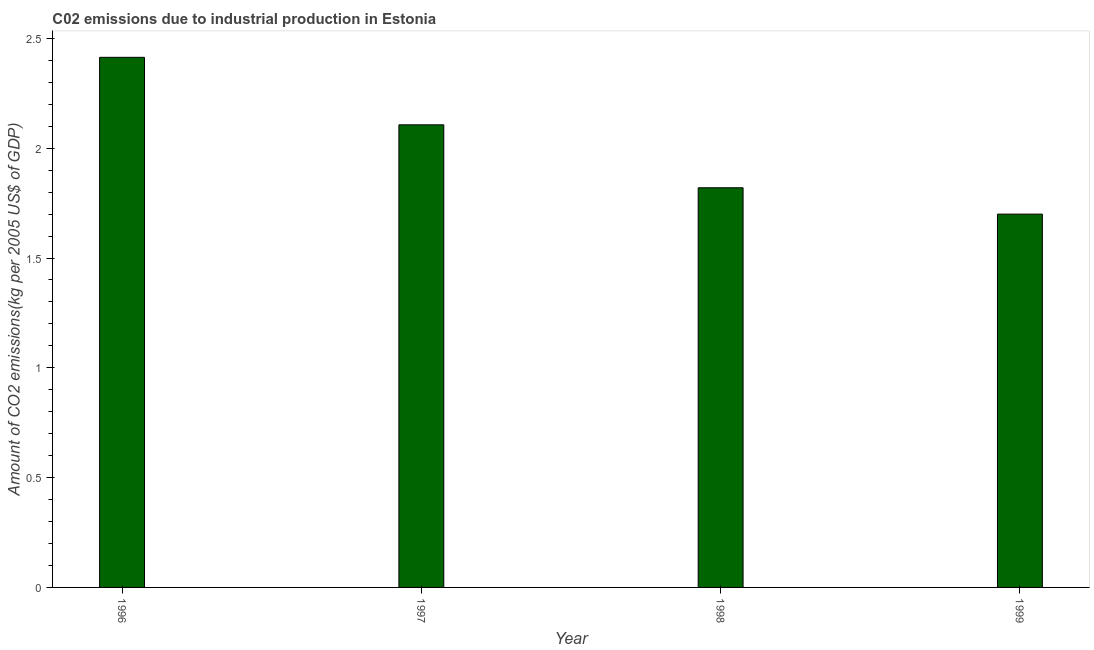What is the title of the graph?
Keep it short and to the point. C02 emissions due to industrial production in Estonia. What is the label or title of the Y-axis?
Your answer should be very brief. Amount of CO2 emissions(kg per 2005 US$ of GDP). What is the amount of co2 emissions in 1998?
Provide a short and direct response. 1.82. Across all years, what is the maximum amount of co2 emissions?
Your answer should be compact. 2.41. Across all years, what is the minimum amount of co2 emissions?
Offer a very short reply. 1.7. In which year was the amount of co2 emissions maximum?
Your answer should be compact. 1996. In which year was the amount of co2 emissions minimum?
Give a very brief answer. 1999. What is the sum of the amount of co2 emissions?
Your response must be concise. 8.04. What is the difference between the amount of co2 emissions in 1996 and 1997?
Your response must be concise. 0.31. What is the average amount of co2 emissions per year?
Your answer should be very brief. 2.01. What is the median amount of co2 emissions?
Ensure brevity in your answer.  1.96. In how many years, is the amount of co2 emissions greater than 1.9 kg per 2005 US$ of GDP?
Ensure brevity in your answer.  2. What is the ratio of the amount of co2 emissions in 1997 to that in 1998?
Make the answer very short. 1.16. Is the amount of co2 emissions in 1997 less than that in 1999?
Provide a short and direct response. No. Is the difference between the amount of co2 emissions in 1998 and 1999 greater than the difference between any two years?
Give a very brief answer. No. What is the difference between the highest and the second highest amount of co2 emissions?
Offer a very short reply. 0.31. Is the sum of the amount of co2 emissions in 1996 and 1999 greater than the maximum amount of co2 emissions across all years?
Your answer should be compact. Yes. What is the difference between the highest and the lowest amount of co2 emissions?
Make the answer very short. 0.71. In how many years, is the amount of co2 emissions greater than the average amount of co2 emissions taken over all years?
Ensure brevity in your answer.  2. How many bars are there?
Your response must be concise. 4. What is the difference between two consecutive major ticks on the Y-axis?
Provide a short and direct response. 0.5. Are the values on the major ticks of Y-axis written in scientific E-notation?
Provide a short and direct response. No. What is the Amount of CO2 emissions(kg per 2005 US$ of GDP) of 1996?
Keep it short and to the point. 2.41. What is the Amount of CO2 emissions(kg per 2005 US$ of GDP) of 1997?
Make the answer very short. 2.11. What is the Amount of CO2 emissions(kg per 2005 US$ of GDP) in 1998?
Make the answer very short. 1.82. What is the Amount of CO2 emissions(kg per 2005 US$ of GDP) of 1999?
Ensure brevity in your answer.  1.7. What is the difference between the Amount of CO2 emissions(kg per 2005 US$ of GDP) in 1996 and 1997?
Make the answer very short. 0.31. What is the difference between the Amount of CO2 emissions(kg per 2005 US$ of GDP) in 1996 and 1998?
Provide a succinct answer. 0.59. What is the difference between the Amount of CO2 emissions(kg per 2005 US$ of GDP) in 1996 and 1999?
Provide a short and direct response. 0.71. What is the difference between the Amount of CO2 emissions(kg per 2005 US$ of GDP) in 1997 and 1998?
Give a very brief answer. 0.29. What is the difference between the Amount of CO2 emissions(kg per 2005 US$ of GDP) in 1997 and 1999?
Provide a short and direct response. 0.41. What is the difference between the Amount of CO2 emissions(kg per 2005 US$ of GDP) in 1998 and 1999?
Make the answer very short. 0.12. What is the ratio of the Amount of CO2 emissions(kg per 2005 US$ of GDP) in 1996 to that in 1997?
Give a very brief answer. 1.15. What is the ratio of the Amount of CO2 emissions(kg per 2005 US$ of GDP) in 1996 to that in 1998?
Offer a very short reply. 1.33. What is the ratio of the Amount of CO2 emissions(kg per 2005 US$ of GDP) in 1996 to that in 1999?
Provide a short and direct response. 1.42. What is the ratio of the Amount of CO2 emissions(kg per 2005 US$ of GDP) in 1997 to that in 1998?
Offer a terse response. 1.16. What is the ratio of the Amount of CO2 emissions(kg per 2005 US$ of GDP) in 1997 to that in 1999?
Ensure brevity in your answer.  1.24. What is the ratio of the Amount of CO2 emissions(kg per 2005 US$ of GDP) in 1998 to that in 1999?
Your answer should be compact. 1.07. 